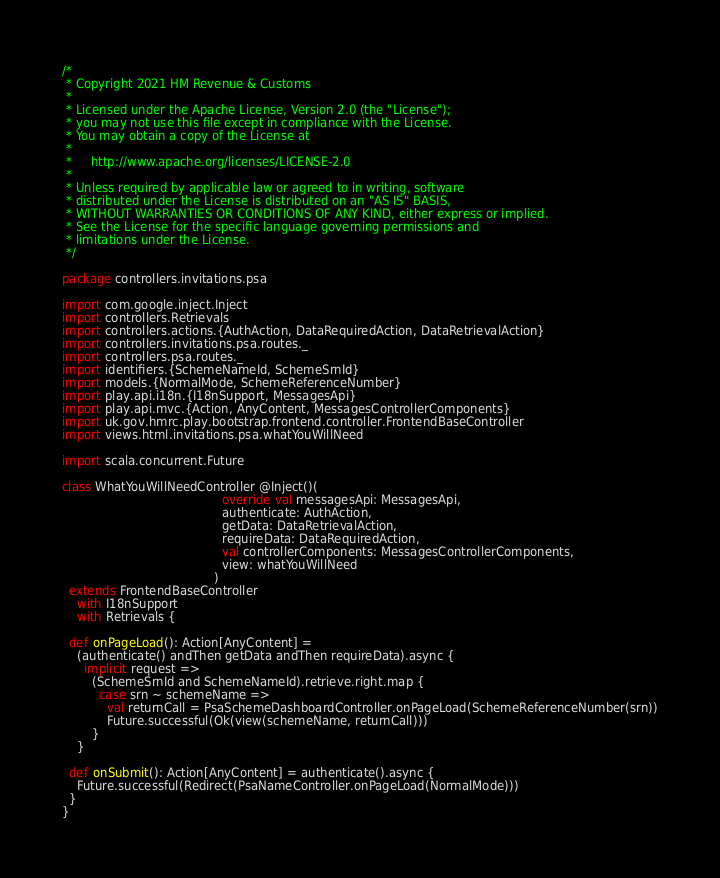<code> <loc_0><loc_0><loc_500><loc_500><_Scala_>/*
 * Copyright 2021 HM Revenue & Customs
 *
 * Licensed under the Apache License, Version 2.0 (the "License");
 * you may not use this file except in compliance with the License.
 * You may obtain a copy of the License at
 *
 *     http://www.apache.org/licenses/LICENSE-2.0
 *
 * Unless required by applicable law or agreed to in writing, software
 * distributed under the License is distributed on an "AS IS" BASIS,
 * WITHOUT WARRANTIES OR CONDITIONS OF ANY KIND, either express or implied.
 * See the License for the specific language governing permissions and
 * limitations under the License.
 */

package controllers.invitations.psa

import com.google.inject.Inject
import controllers.Retrievals
import controllers.actions.{AuthAction, DataRequiredAction, DataRetrievalAction}
import controllers.invitations.psa.routes._
import controllers.psa.routes._
import identifiers.{SchemeNameId, SchemeSrnId}
import models.{NormalMode, SchemeReferenceNumber}
import play.api.i18n.{I18nSupport, MessagesApi}
import play.api.mvc.{Action, AnyContent, MessagesControllerComponents}
import uk.gov.hmrc.play.bootstrap.frontend.controller.FrontendBaseController
import views.html.invitations.psa.whatYouWillNeed

import scala.concurrent.Future

class WhatYouWillNeedController @Inject()(
                                           override val messagesApi: MessagesApi,
                                           authenticate: AuthAction,
                                           getData: DataRetrievalAction,
                                           requireData: DataRequiredAction,
                                           val controllerComponents: MessagesControllerComponents,
                                           view: whatYouWillNeed
                                         )
  extends FrontendBaseController
    with I18nSupport
    with Retrievals {

  def onPageLoad(): Action[AnyContent] =
    (authenticate() andThen getData andThen requireData).async {
      implicit request =>
        (SchemeSrnId and SchemeNameId).retrieve.right.map {
          case srn ~ schemeName =>
            val returnCall = PsaSchemeDashboardController.onPageLoad(SchemeReferenceNumber(srn))
            Future.successful(Ok(view(schemeName, returnCall)))
        }
    }

  def onSubmit(): Action[AnyContent] = authenticate().async {
    Future.successful(Redirect(PsaNameController.onPageLoad(NormalMode)))
  }
}
</code> 